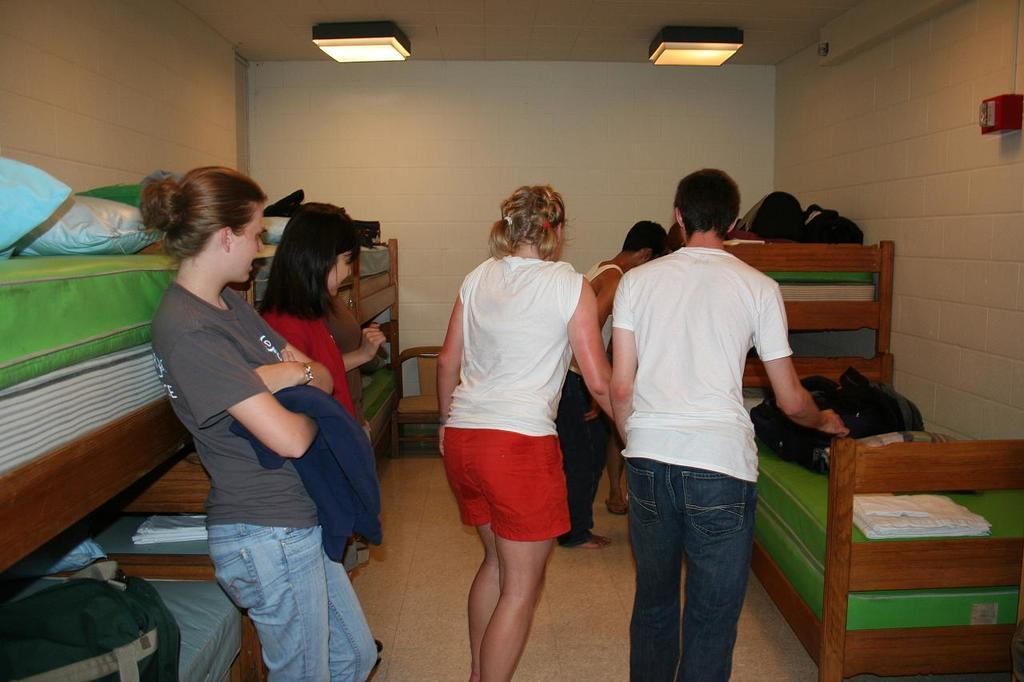What are the people in the image doing? The people in the image are standing beside beds. What is behind the people in the image? There is a wall behind the people in the image. What is visible at the top of the image? The image has a roof visible at the top. What can be seen providing illumination in the image? There are lights visible in the image. What type of pollution is visible in the image? There is no visible pollution in the image. What unit is being measured by the people in the image? The image does not show any units being measured or any indication of what the people might be doing besides standing beside beds. 